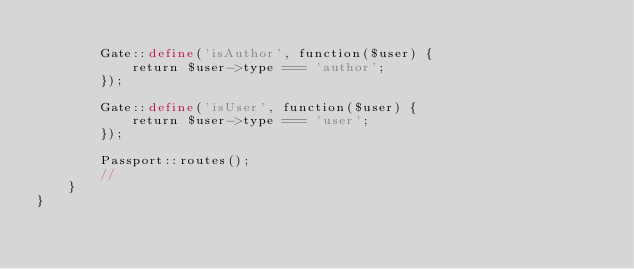Convert code to text. <code><loc_0><loc_0><loc_500><loc_500><_PHP_>
        Gate::define('isAuthor', function($user) {
            return $user->type === 'author';
        });

        Gate::define('isUser', function($user) {
            return $user->type === 'user';
        });

        Passport::routes();
        //
    }
}
</code> 